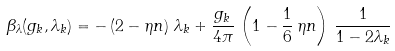Convert formula to latex. <formula><loc_0><loc_0><loc_500><loc_500>\beta _ { \lambda } ( g _ { k } , \lambda _ { k } ) & = - \left ( 2 - \eta n \right ) \, \lambda _ { k } + \frac { g _ { k } } { 4 \pi } \, \left ( 1 - \frac { 1 } { 6 } \, \eta n \right ) \, \frac { 1 } { 1 - 2 \lambda _ { k } }</formula> 